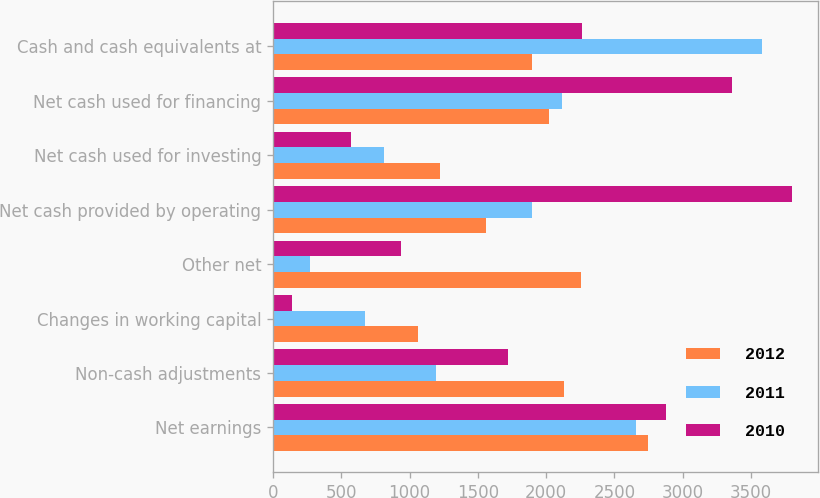Convert chart. <chart><loc_0><loc_0><loc_500><loc_500><stacked_bar_chart><ecel><fcel>Net earnings<fcel>Non-cash adjustments<fcel>Changes in working capital<fcel>Other net<fcel>Net cash provided by operating<fcel>Net cash used for investing<fcel>Net cash used for financing<fcel>Cash and cash equivalents at<nl><fcel>2012<fcel>2745<fcel>2133<fcel>1061<fcel>2256<fcel>1561<fcel>1222<fcel>2023<fcel>1898<nl><fcel>2011<fcel>2655<fcel>1194<fcel>674<fcel>270<fcel>1898<fcel>813<fcel>2119<fcel>3582<nl><fcel>2010<fcel>2878<fcel>1721<fcel>138<fcel>936<fcel>3801<fcel>573<fcel>3358<fcel>2261<nl></chart> 